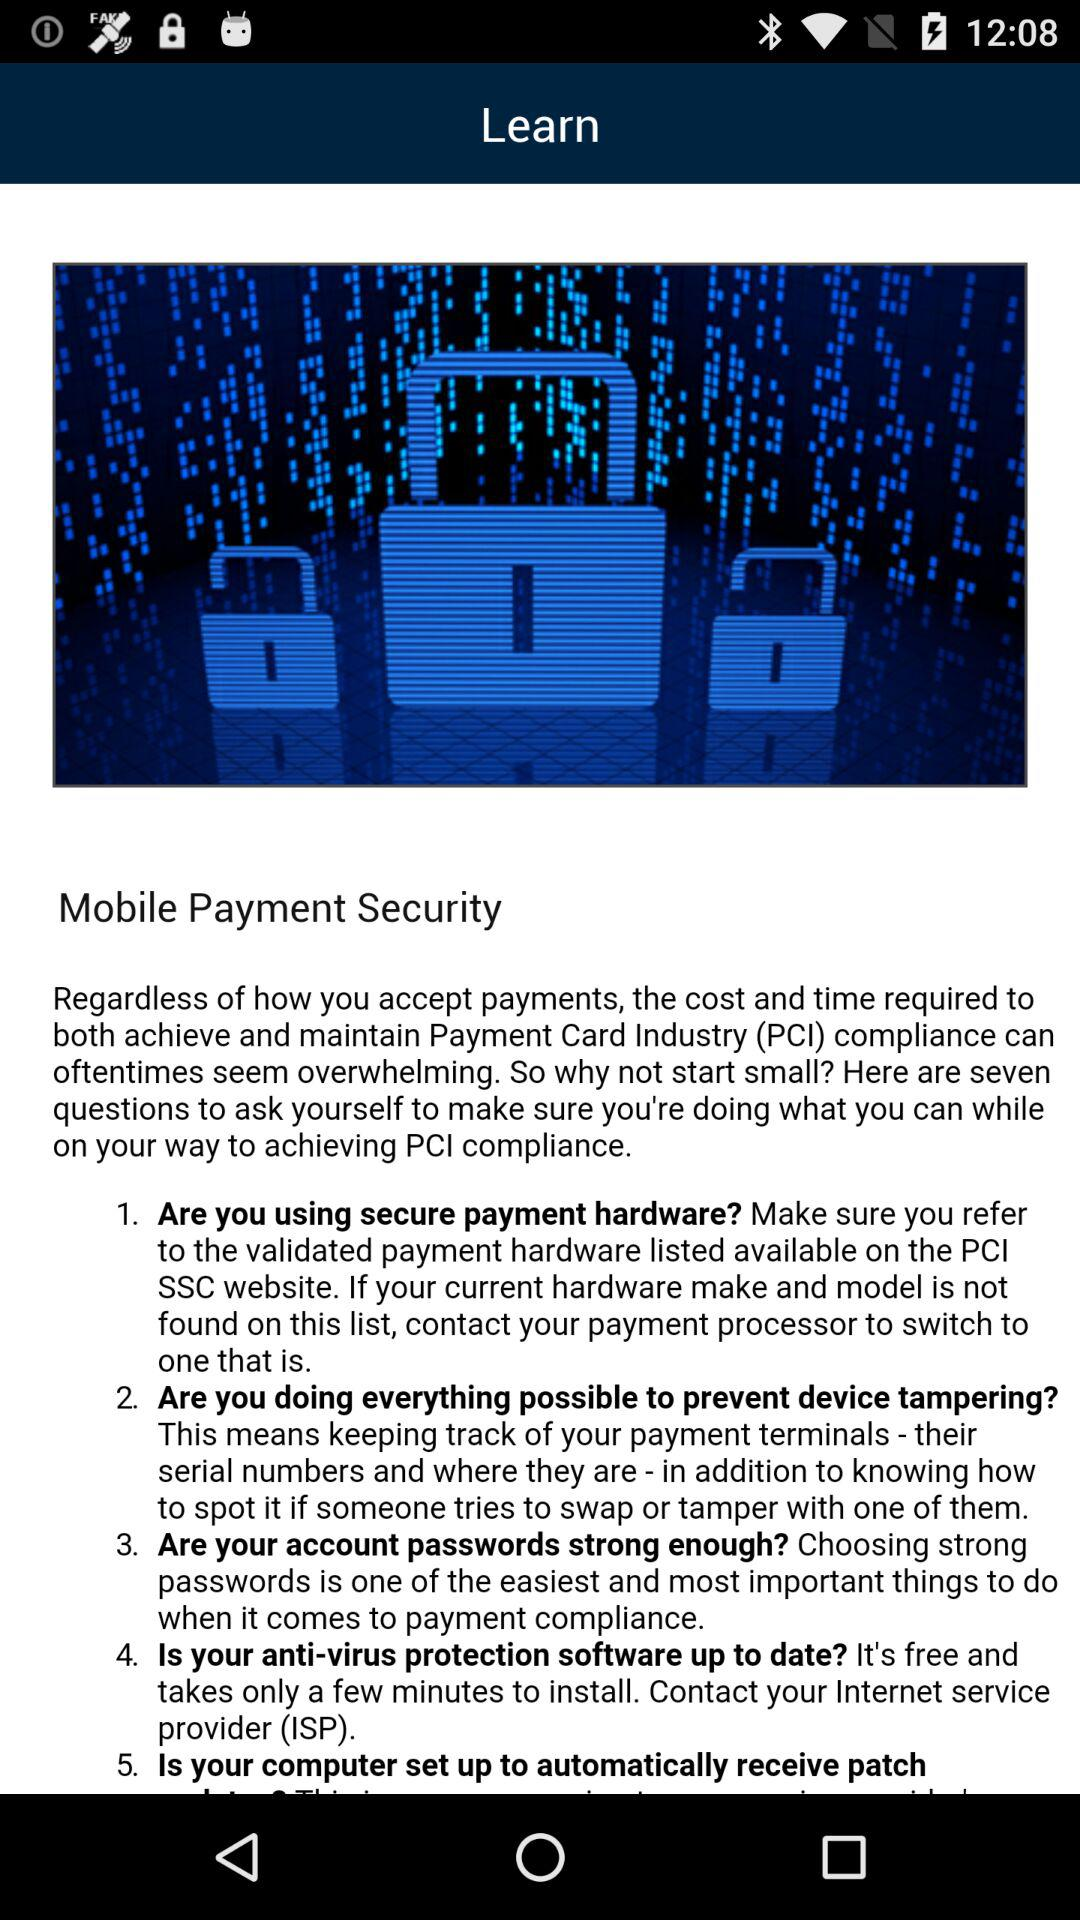What is the full form of PCI? The full form is "Payment Card Industry". 